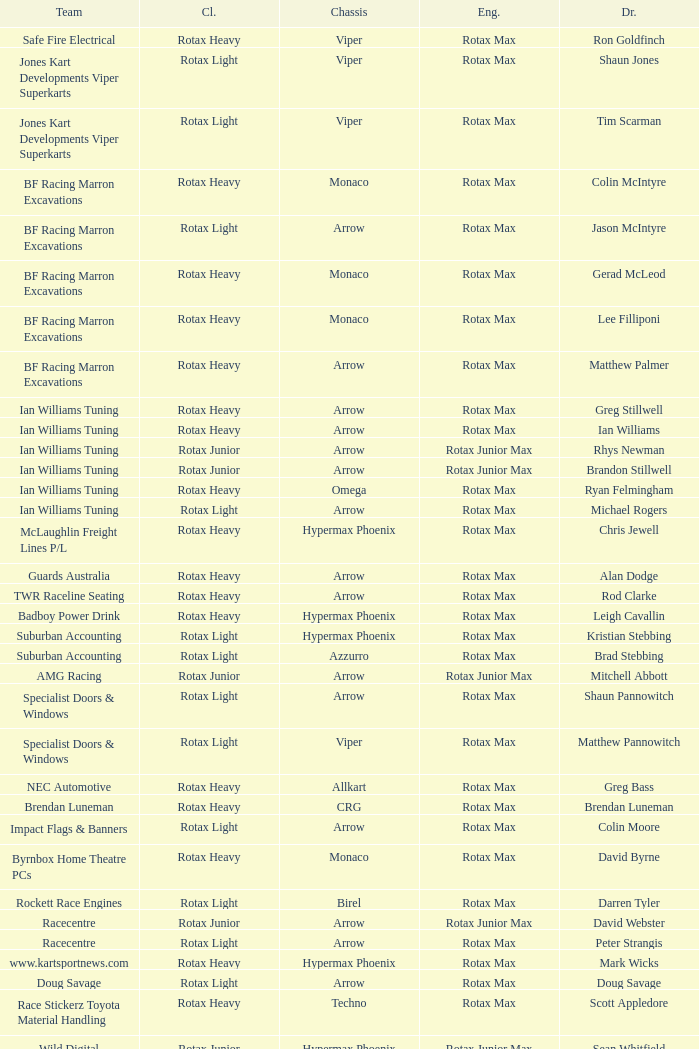What is the name of the driver with a rotax max engine, in the rotax heavy class, with arrow as chassis and on the TWR Raceline Seating team? Rod Clarke. 